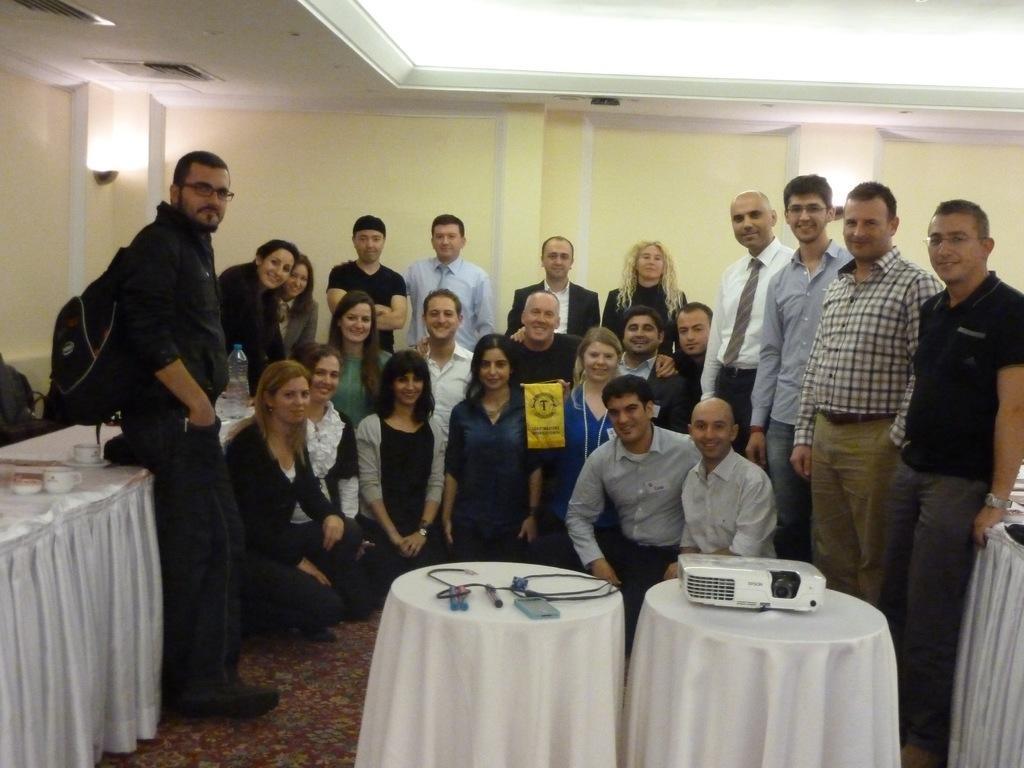In one or two sentences, can you explain what this image depicts? Few persons are standing. Few persons are sitting. We can see tables. On the table we can see bottle,cap,cable,projector,cloth. This is floor. On the background we can see wall. 